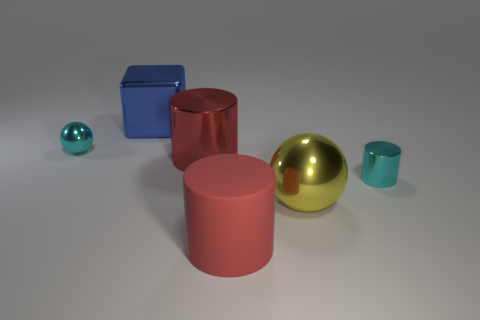The cylinder that is the same color as the small sphere is what size?
Offer a very short reply. Small. What is the material of the big thing in front of the yellow sphere?
Your response must be concise. Rubber. How big is the cyan metal object that is right of the tiny object on the left side of the big thing that is to the left of the big red shiny cylinder?
Give a very brief answer. Small. Are the small cyan object that is on the left side of the cube and the tiny cyan object on the right side of the blue metallic cube made of the same material?
Keep it short and to the point. Yes. What number of other things are there of the same color as the big shiny block?
Your answer should be very brief. 0. What number of objects are either metallic spheres right of the small metal sphere or cyan shiny things to the left of the yellow thing?
Offer a very short reply. 2. What is the size of the cyan object in front of the tiny metallic object that is to the left of the large blue shiny block?
Offer a terse response. Small. What size is the cyan sphere?
Your answer should be very brief. Small. There is a tiny object to the right of the small sphere; is its color the same as the shiny ball on the left side of the big red shiny cylinder?
Your answer should be compact. Yes. What number of other things are there of the same material as the large blue block
Offer a very short reply. 4. 